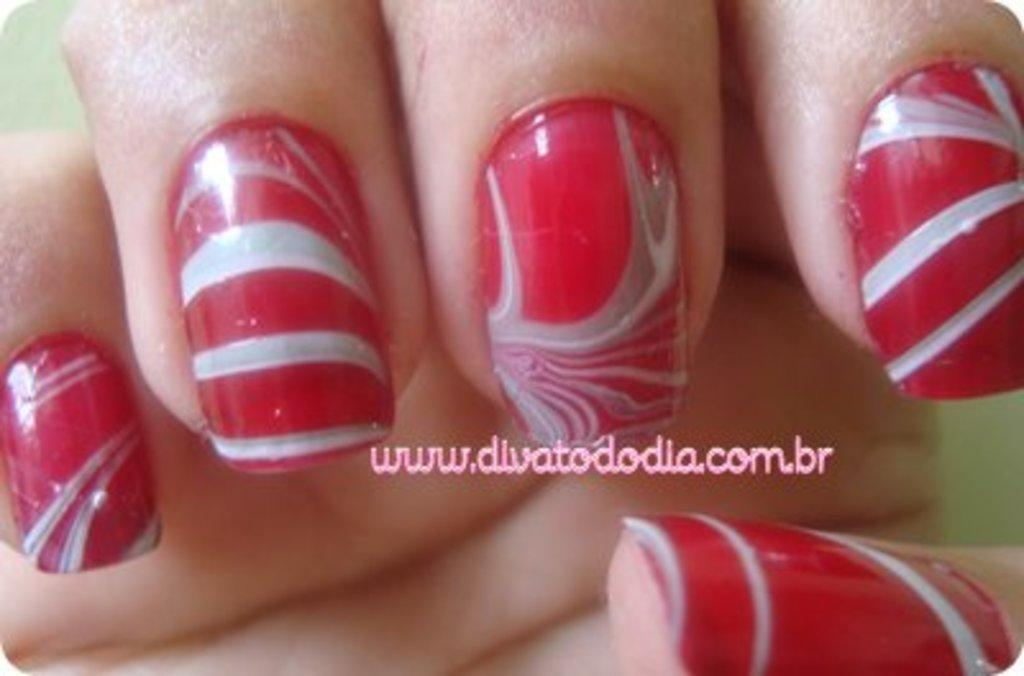<image>
Create a compact narrative representing the image presented. A set of painted fingernails with the website divatododia listed. 